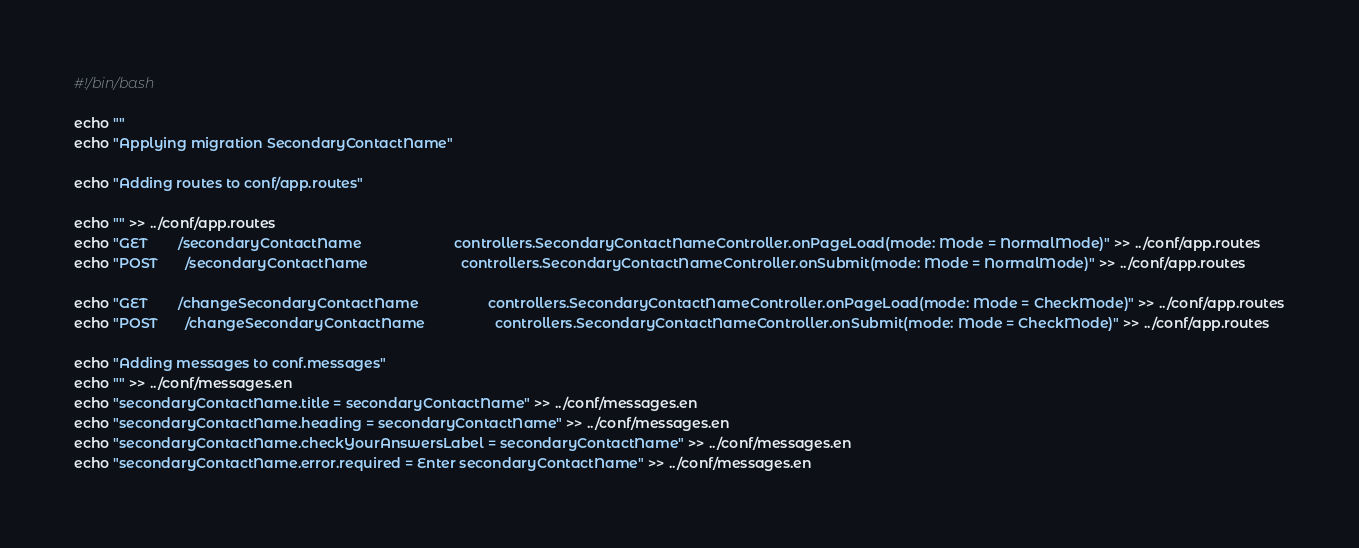Convert code to text. <code><loc_0><loc_0><loc_500><loc_500><_Bash_>#!/bin/bash

echo ""
echo "Applying migration SecondaryContactName"

echo "Adding routes to conf/app.routes"

echo "" >> ../conf/app.routes
echo "GET        /secondaryContactName                        controllers.SecondaryContactNameController.onPageLoad(mode: Mode = NormalMode)" >> ../conf/app.routes
echo "POST       /secondaryContactName                        controllers.SecondaryContactNameController.onSubmit(mode: Mode = NormalMode)" >> ../conf/app.routes

echo "GET        /changeSecondaryContactName                  controllers.SecondaryContactNameController.onPageLoad(mode: Mode = CheckMode)" >> ../conf/app.routes
echo "POST       /changeSecondaryContactName                  controllers.SecondaryContactNameController.onSubmit(mode: Mode = CheckMode)" >> ../conf/app.routes

echo "Adding messages to conf.messages"
echo "" >> ../conf/messages.en
echo "secondaryContactName.title = secondaryContactName" >> ../conf/messages.en
echo "secondaryContactName.heading = secondaryContactName" >> ../conf/messages.en
echo "secondaryContactName.checkYourAnswersLabel = secondaryContactName" >> ../conf/messages.en
echo "secondaryContactName.error.required = Enter secondaryContactName" >> ../conf/messages.en</code> 